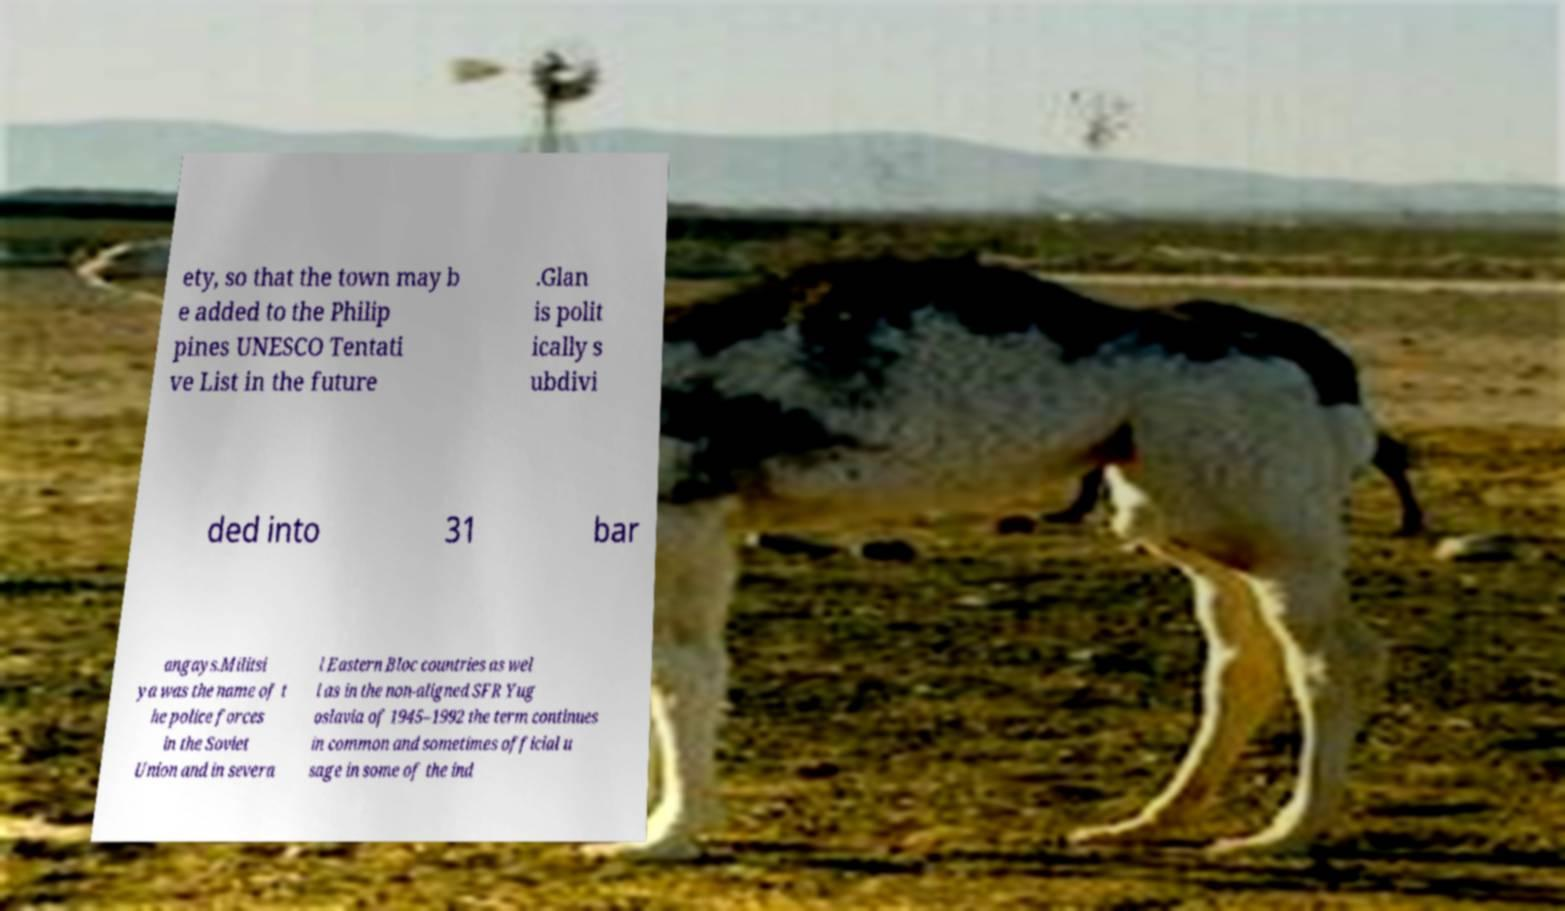What messages or text are displayed in this image? I need them in a readable, typed format. ety, so that the town may b e added to the Philip pines UNESCO Tentati ve List in the future .Glan is polit ically s ubdivi ded into 31 bar angays.Militsi ya was the name of t he police forces in the Soviet Union and in severa l Eastern Bloc countries as wel l as in the non-aligned SFR Yug oslavia of 1945–1992 the term continues in common and sometimes official u sage in some of the ind 